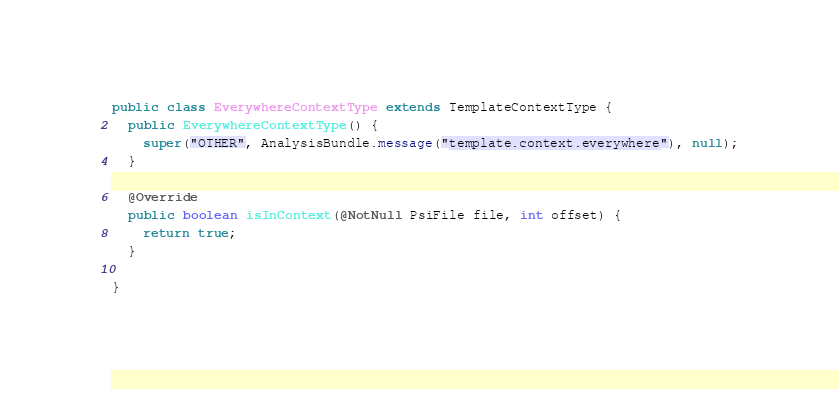Convert code to text. <code><loc_0><loc_0><loc_500><loc_500><_Java_>

public class EverywhereContextType extends TemplateContextType {
  public EverywhereContextType() {
    super("OTHER", AnalysisBundle.message("template.context.everywhere"), null);
  }

  @Override
  public boolean isInContext(@NotNull PsiFile file, int offset) {
    return true;
  }

}
</code> 